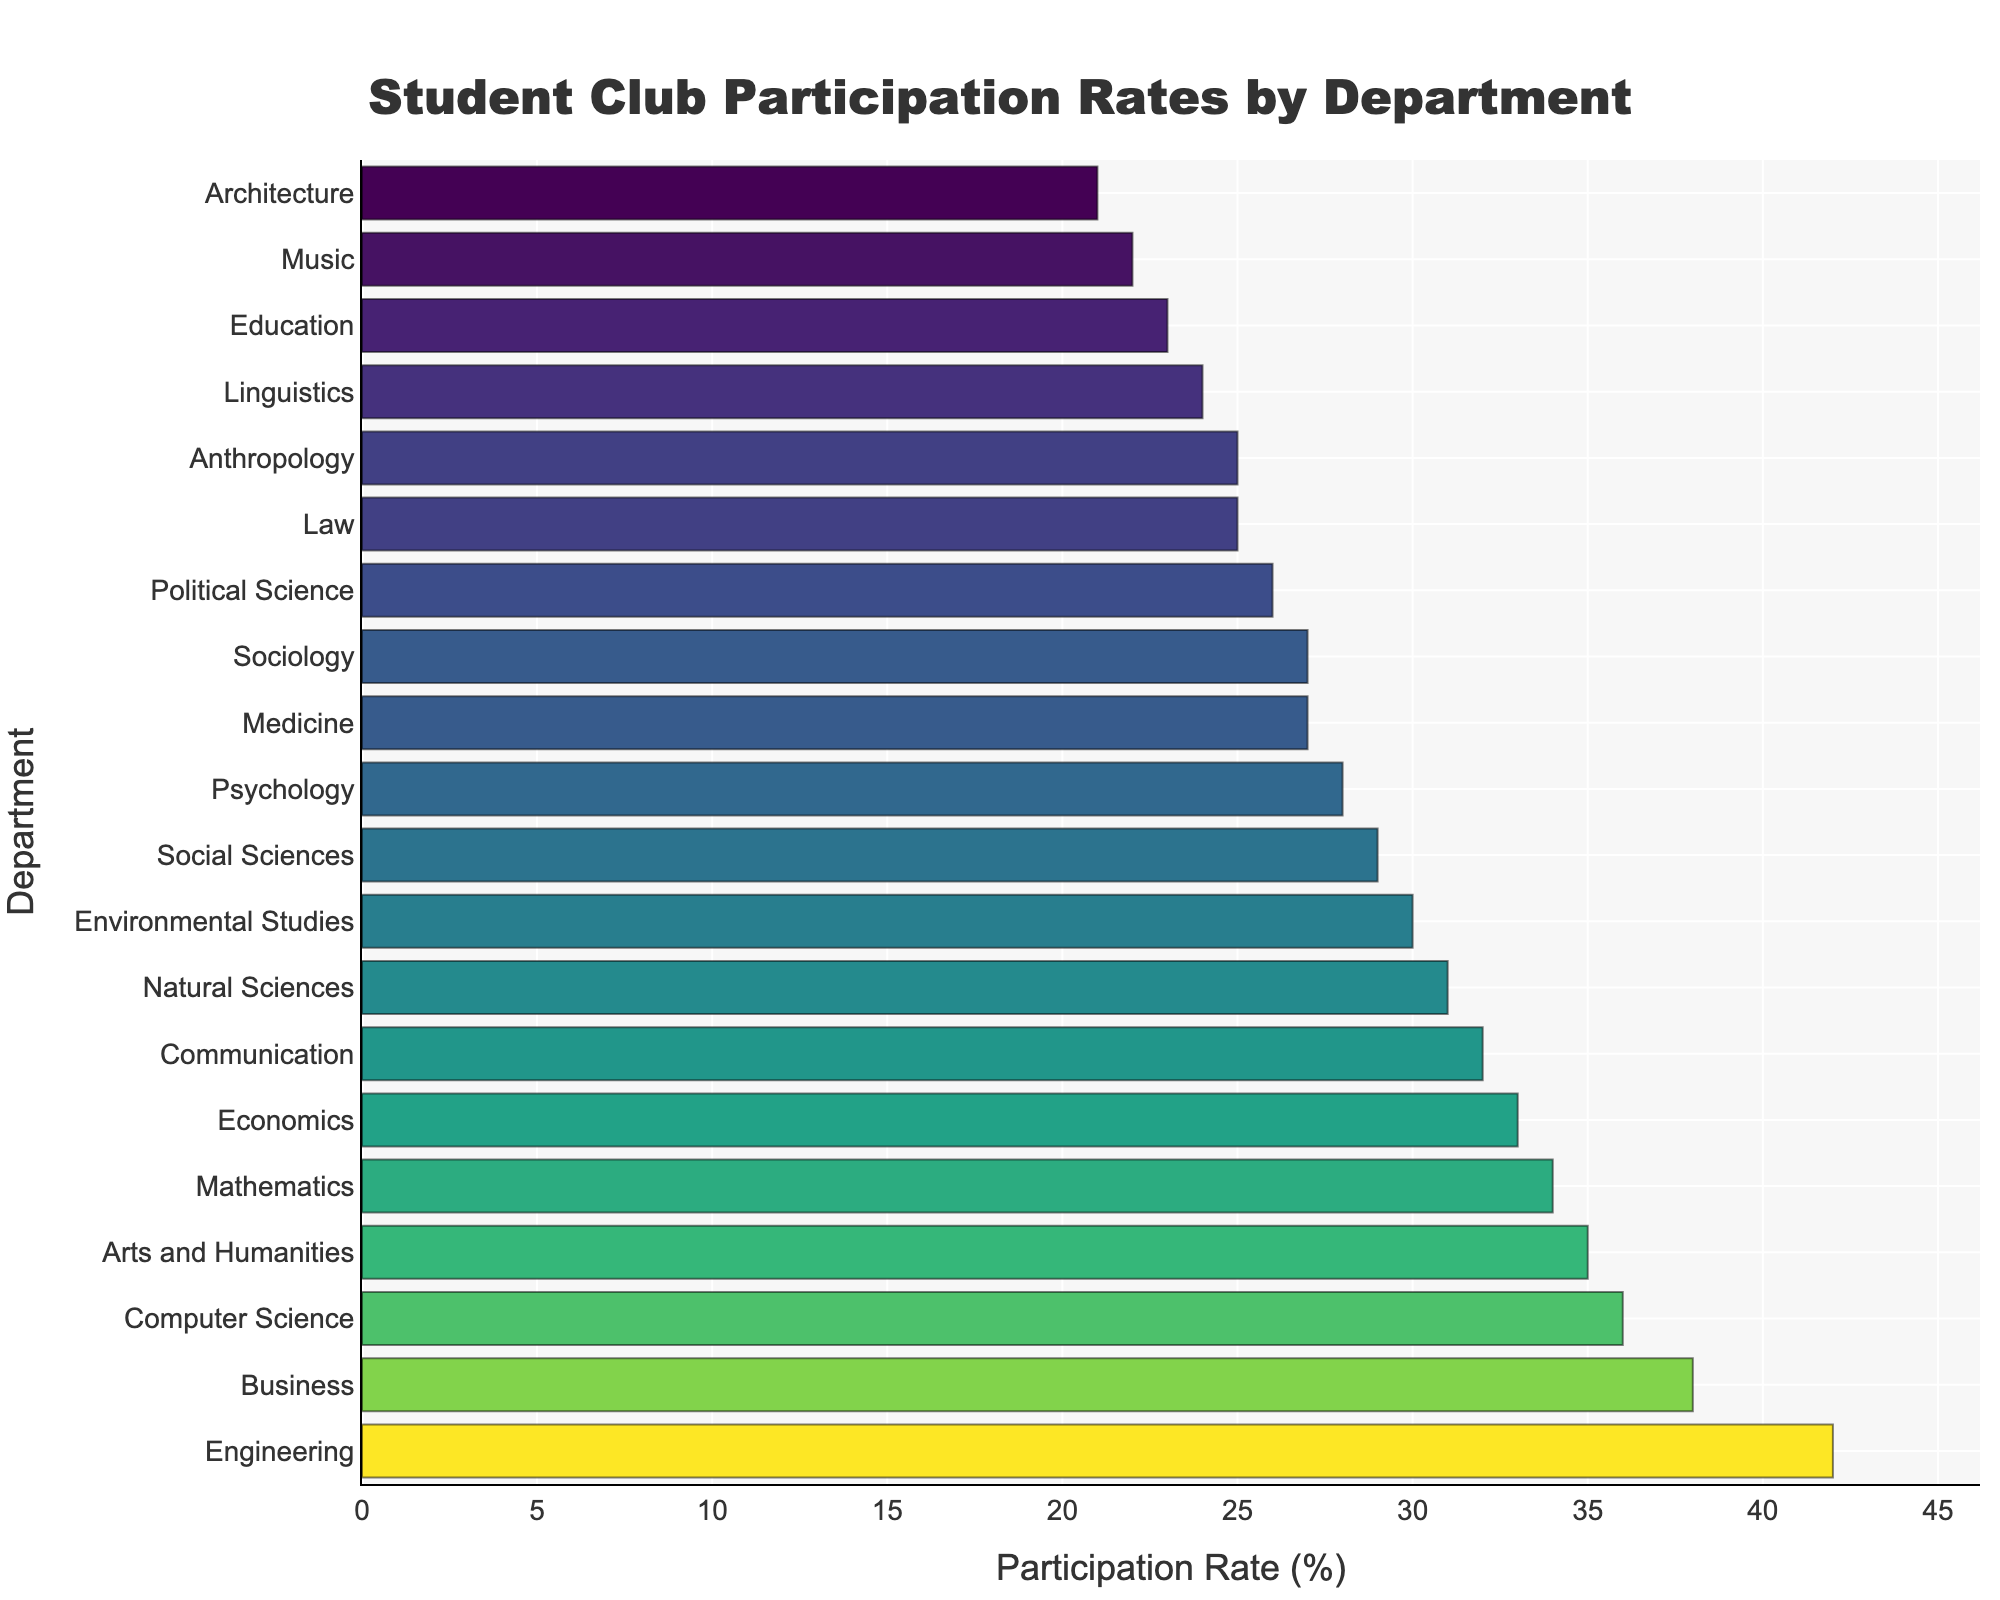Which department has the highest participation rate? Look at the bar that is the longest, which represents the highest participation rate. The longest bar belongs to the Engineering department.
Answer: Engineering Which department has the lowest participation rate? Look at the bar that is the shortest, which represents the lowest participation rate. The shortest bar belongs to the Architecture department.
Answer: Architecture How much higher is the participation rate in Engineering compared to Medicine? Find the participation rates for both departments from the bar lengths. Engineering is 42% and Medicine is 27%. The difference is 42 - 27 = 15%.
Answer: 15% What is the combined participation rate for Arts and Humanities, and Social Sciences? Find the participation rates for both departments. Arts and Humanities is 35% and Social Sciences is 29%. The combined participation rate is 35 + 29 = 64%.
Answer: 64% Which departments have participation rates greater than 30% but less than 40%? Identify the bars whose participation rates fall within the range 30% to 40%. These include Business (38%), Computer Science (36%), Arts and Humanities (35%), Mathematics (34%), Economics (33%), and Communication (32%).
Answer: Business, Computer Science, Arts and Humanities, Mathematics, Economics, Communication Between Political Science and Linguistics, which has a lower participation rate, and by how much? Find the participation rates for both departments. Political Science is 26% and Linguistics is 24%. The difference is 26 - 24 = 2%. Linguistics has the lower rate by 2%.
Answer: Linguistics, 2% Rank the top three departments in terms of participation rate. Identify the top three longest bars, representing the highest participation rates. These are Engineering (42%), Business (38%), and Computer Science (36%).
Answer: Engineering, Business, Computer Science How much higher is the average participation rate of the top three departments compared to the bottom three? Calculate the average participation rate for the top three (Engineering, Business, Computer Science) which is (42 + 38 + 36)/3 = 38.67%. For the bottom three (Architecture, Music, Education), it is (21 + 22 + 23)/3 = 22%. The difference is 38.67 - 22 = 16.67%.
Answer: 16.67% What is the median participation rate for all departments shown? List all participation rates in ascending order: 21, 22, 23, 24, 25, 25, 26, 27, 27, 28, 29, 30, 31, 32, 33, 34, 35, 36, 38, 42. The middle value for an odd number of data points is the 11th value: 29.
Answer: 29 Identify the departments with participation rates that are equal. Identify any pairs of bars with the same lengths. Social Sciences and Sociology both have participation rates of 27%. Law and Anthropology both have participation rates of 25%.
Answer: Social Sciences and Sociology, Law and Anthropology 